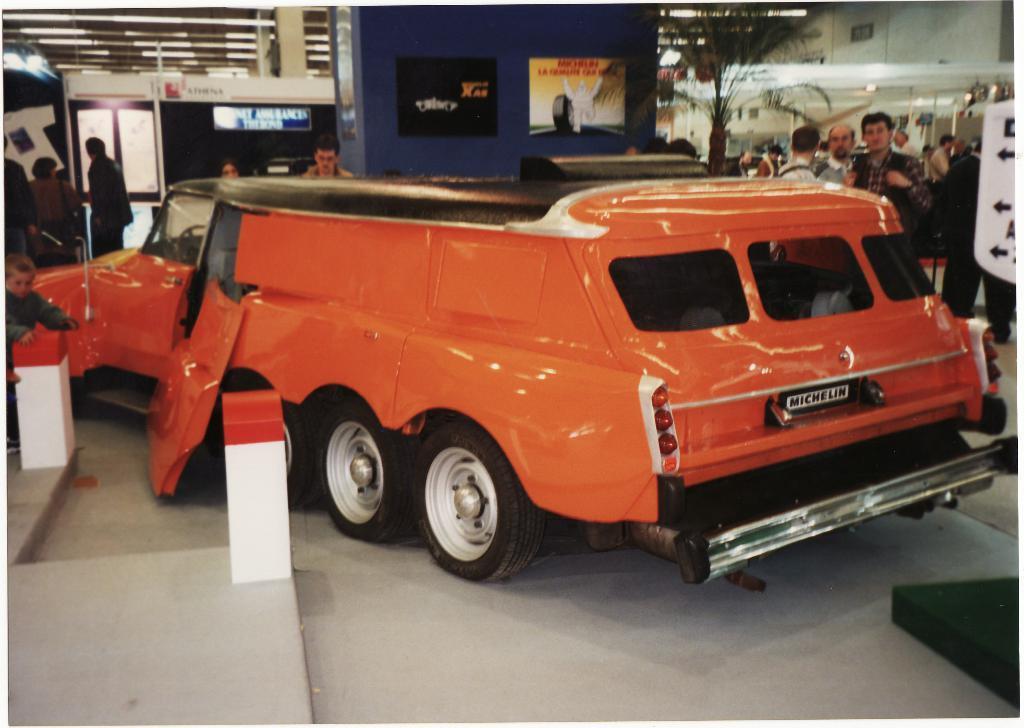What is the main subject in the center of the image? There is a vehicle in the center of the image. What can be seen in the background of the image? There are poles, buildings, lights, boards, trees, and sign boards in the background of the image. What is present at the bottom of the image? There is a floor and a road at the bottom of the image. What type of sticks are being used to plough the field in the image? There is no field or ploughing activity present in the image. Can you make a comparison between the size of the vehicle and the trees in the image? It is not possible to make a comparison between the size of the vehicle and the trees in the image, as the provided facts do not include any information about the relative sizes of these objects. 